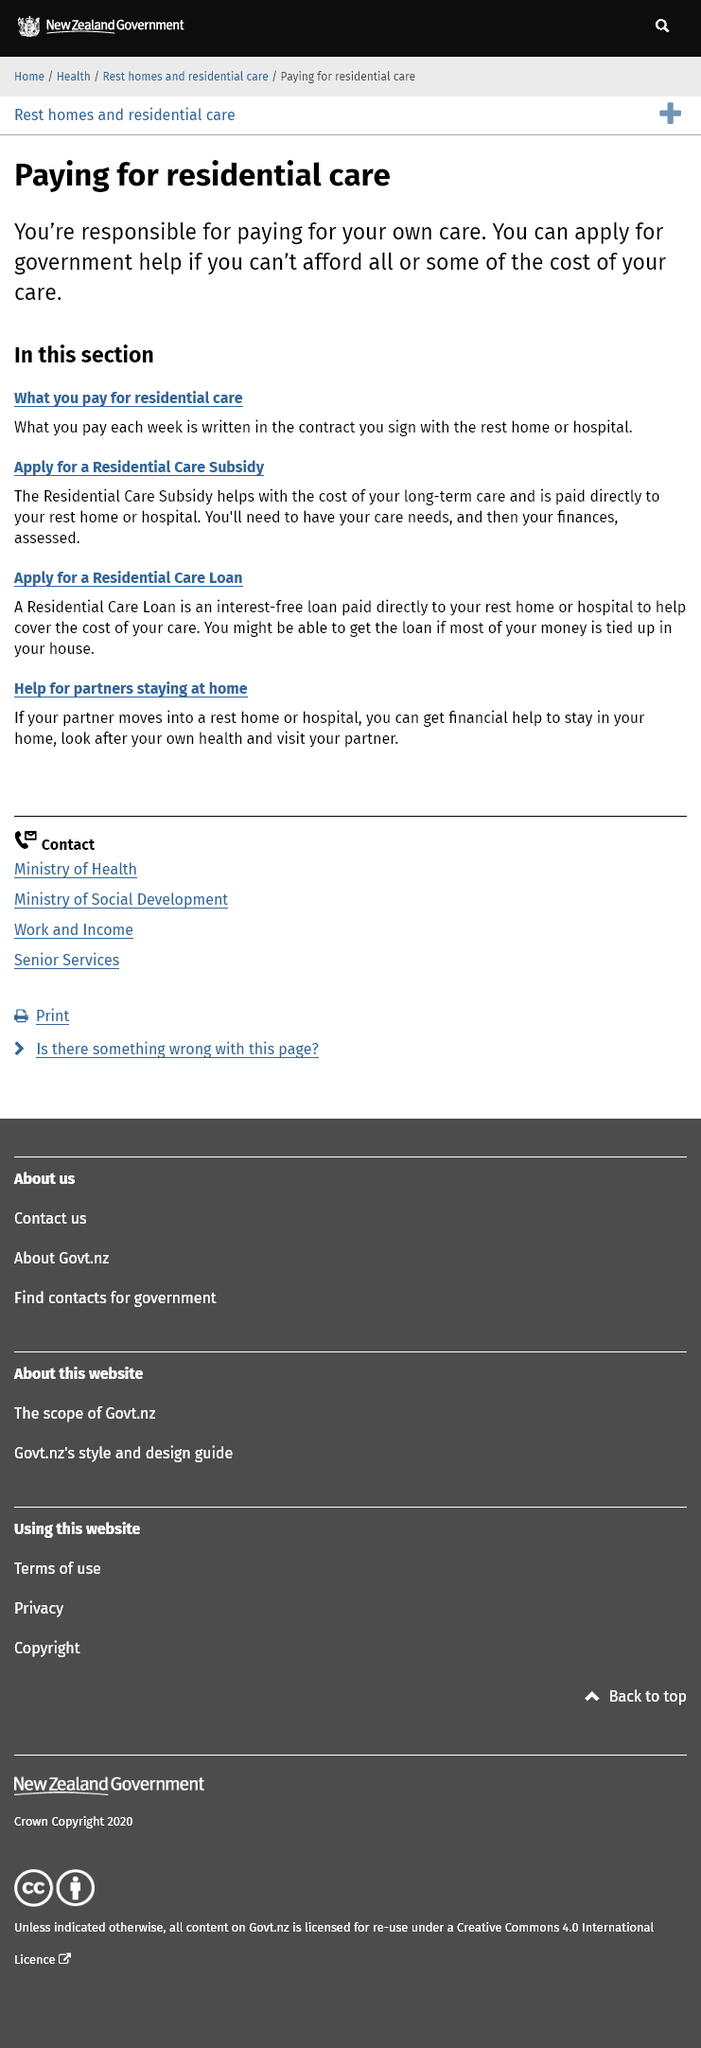Point out several critical features in this image. When applying for a Residential Care Subsidy, it will be necessary to have both your care needs and your finances assessed in order to determine eligibility. It is your responsibility to pay for your own residential care, and you are not entitled to have the costs covered by anyone else. A Residential Care Subsidy, paid directly to a rest home or hospital, helps cover the cost of long-term care, while a Residential Care Loan is an interest-free loan also paid directly to the rest home or hospital to help with the cost of care. 